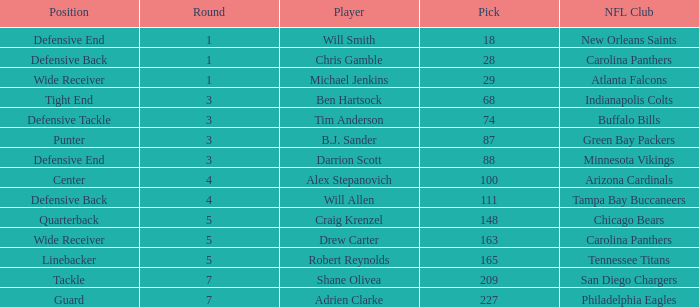Can you parse all the data within this table? {'header': ['Position', 'Round', 'Player', 'Pick', 'NFL Club'], 'rows': [['Defensive End', '1', 'Will Smith', '18', 'New Orleans Saints'], ['Defensive Back', '1', 'Chris Gamble', '28', 'Carolina Panthers'], ['Wide Receiver', '1', 'Michael Jenkins', '29', 'Atlanta Falcons'], ['Tight End', '3', 'Ben Hartsock', '68', 'Indianapolis Colts'], ['Defensive Tackle', '3', 'Tim Anderson', '74', 'Buffalo Bills'], ['Punter', '3', 'B.J. Sander', '87', 'Green Bay Packers'], ['Defensive End', '3', 'Darrion Scott', '88', 'Minnesota Vikings'], ['Center', '4', 'Alex Stepanovich', '100', 'Arizona Cardinals'], ['Defensive Back', '4', 'Will Allen', '111', 'Tampa Bay Buccaneers'], ['Quarterback', '5', 'Craig Krenzel', '148', 'Chicago Bears'], ['Wide Receiver', '5', 'Drew Carter', '163', 'Carolina Panthers'], ['Linebacker', '5', 'Robert Reynolds', '165', 'Tennessee Titans'], ['Tackle', '7', 'Shane Olivea', '209', 'San Diego Chargers'], ['Guard', '7', 'Adrien Clarke', '227', 'Philadelphia Eagles']]} What is the average Round number of Player Adrien Clarke? 7.0. 